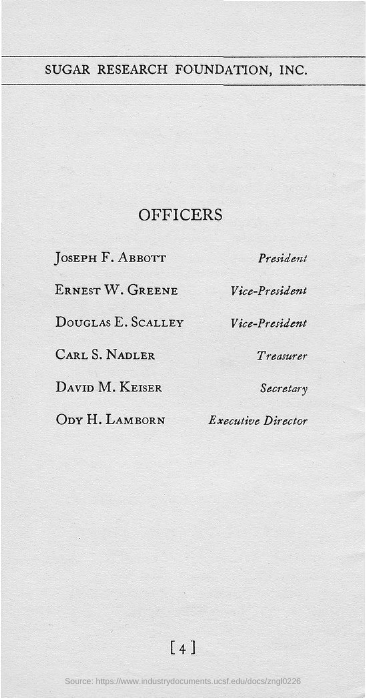Who is the president of Sugar Research Foundation, Inc.?
Offer a very short reply. Joseph f. abbott. Who is the Executive Director of Sugar Research Foundation, Inc.?
Provide a succinct answer. ODY H. LAMBORN. Who is the Secretary of Sugar Research Foundation, Inc.?
Give a very brief answer. DAVID M. KEISER. Who is the treasurer of Sugar Research Foundation, Inc.?
Ensure brevity in your answer.  CARL S. NADLER. 